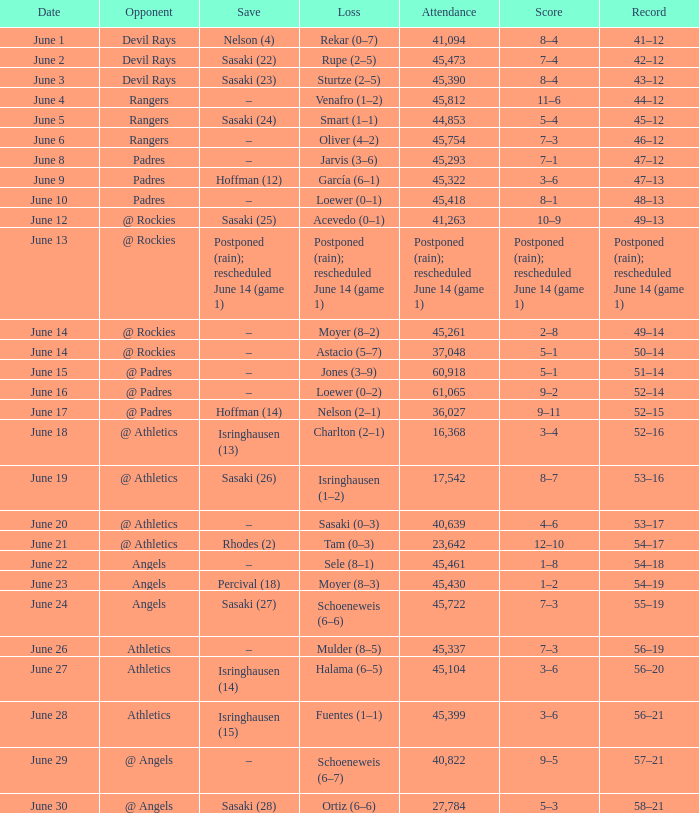What was the date of the Mariners game when they had a record of 53–17? June 20. 